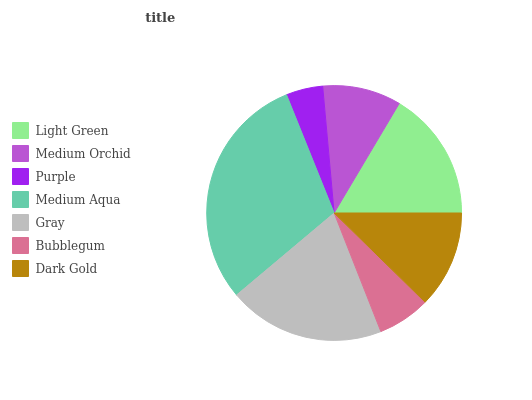Is Purple the minimum?
Answer yes or no. Yes. Is Medium Aqua the maximum?
Answer yes or no. Yes. Is Medium Orchid the minimum?
Answer yes or no. No. Is Medium Orchid the maximum?
Answer yes or no. No. Is Light Green greater than Medium Orchid?
Answer yes or no. Yes. Is Medium Orchid less than Light Green?
Answer yes or no. Yes. Is Medium Orchid greater than Light Green?
Answer yes or no. No. Is Light Green less than Medium Orchid?
Answer yes or no. No. Is Dark Gold the high median?
Answer yes or no. Yes. Is Dark Gold the low median?
Answer yes or no. Yes. Is Light Green the high median?
Answer yes or no. No. Is Gray the low median?
Answer yes or no. No. 